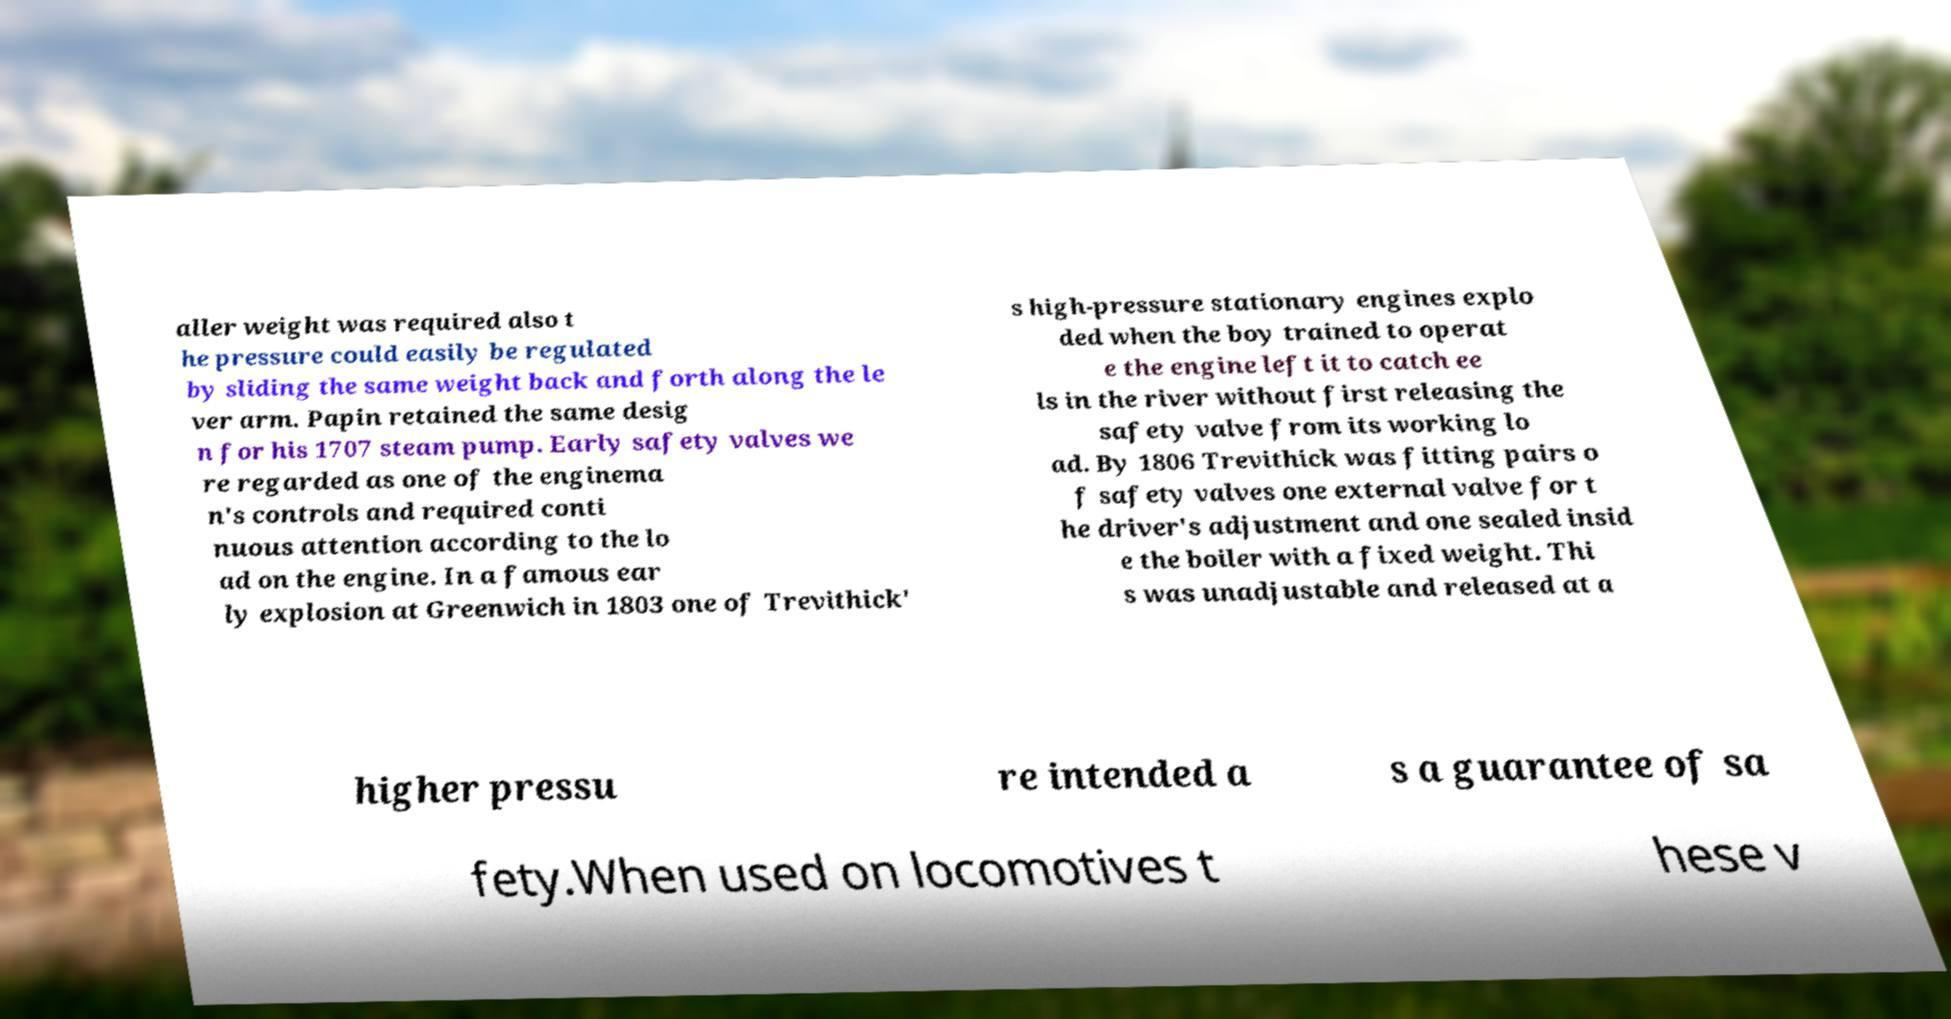Can you accurately transcribe the text from the provided image for me? aller weight was required also t he pressure could easily be regulated by sliding the same weight back and forth along the le ver arm. Papin retained the same desig n for his 1707 steam pump. Early safety valves we re regarded as one of the enginema n's controls and required conti nuous attention according to the lo ad on the engine. In a famous ear ly explosion at Greenwich in 1803 one of Trevithick' s high-pressure stationary engines explo ded when the boy trained to operat e the engine left it to catch ee ls in the river without first releasing the safety valve from its working lo ad. By 1806 Trevithick was fitting pairs o f safety valves one external valve for t he driver's adjustment and one sealed insid e the boiler with a fixed weight. Thi s was unadjustable and released at a higher pressu re intended a s a guarantee of sa fety.When used on locomotives t hese v 